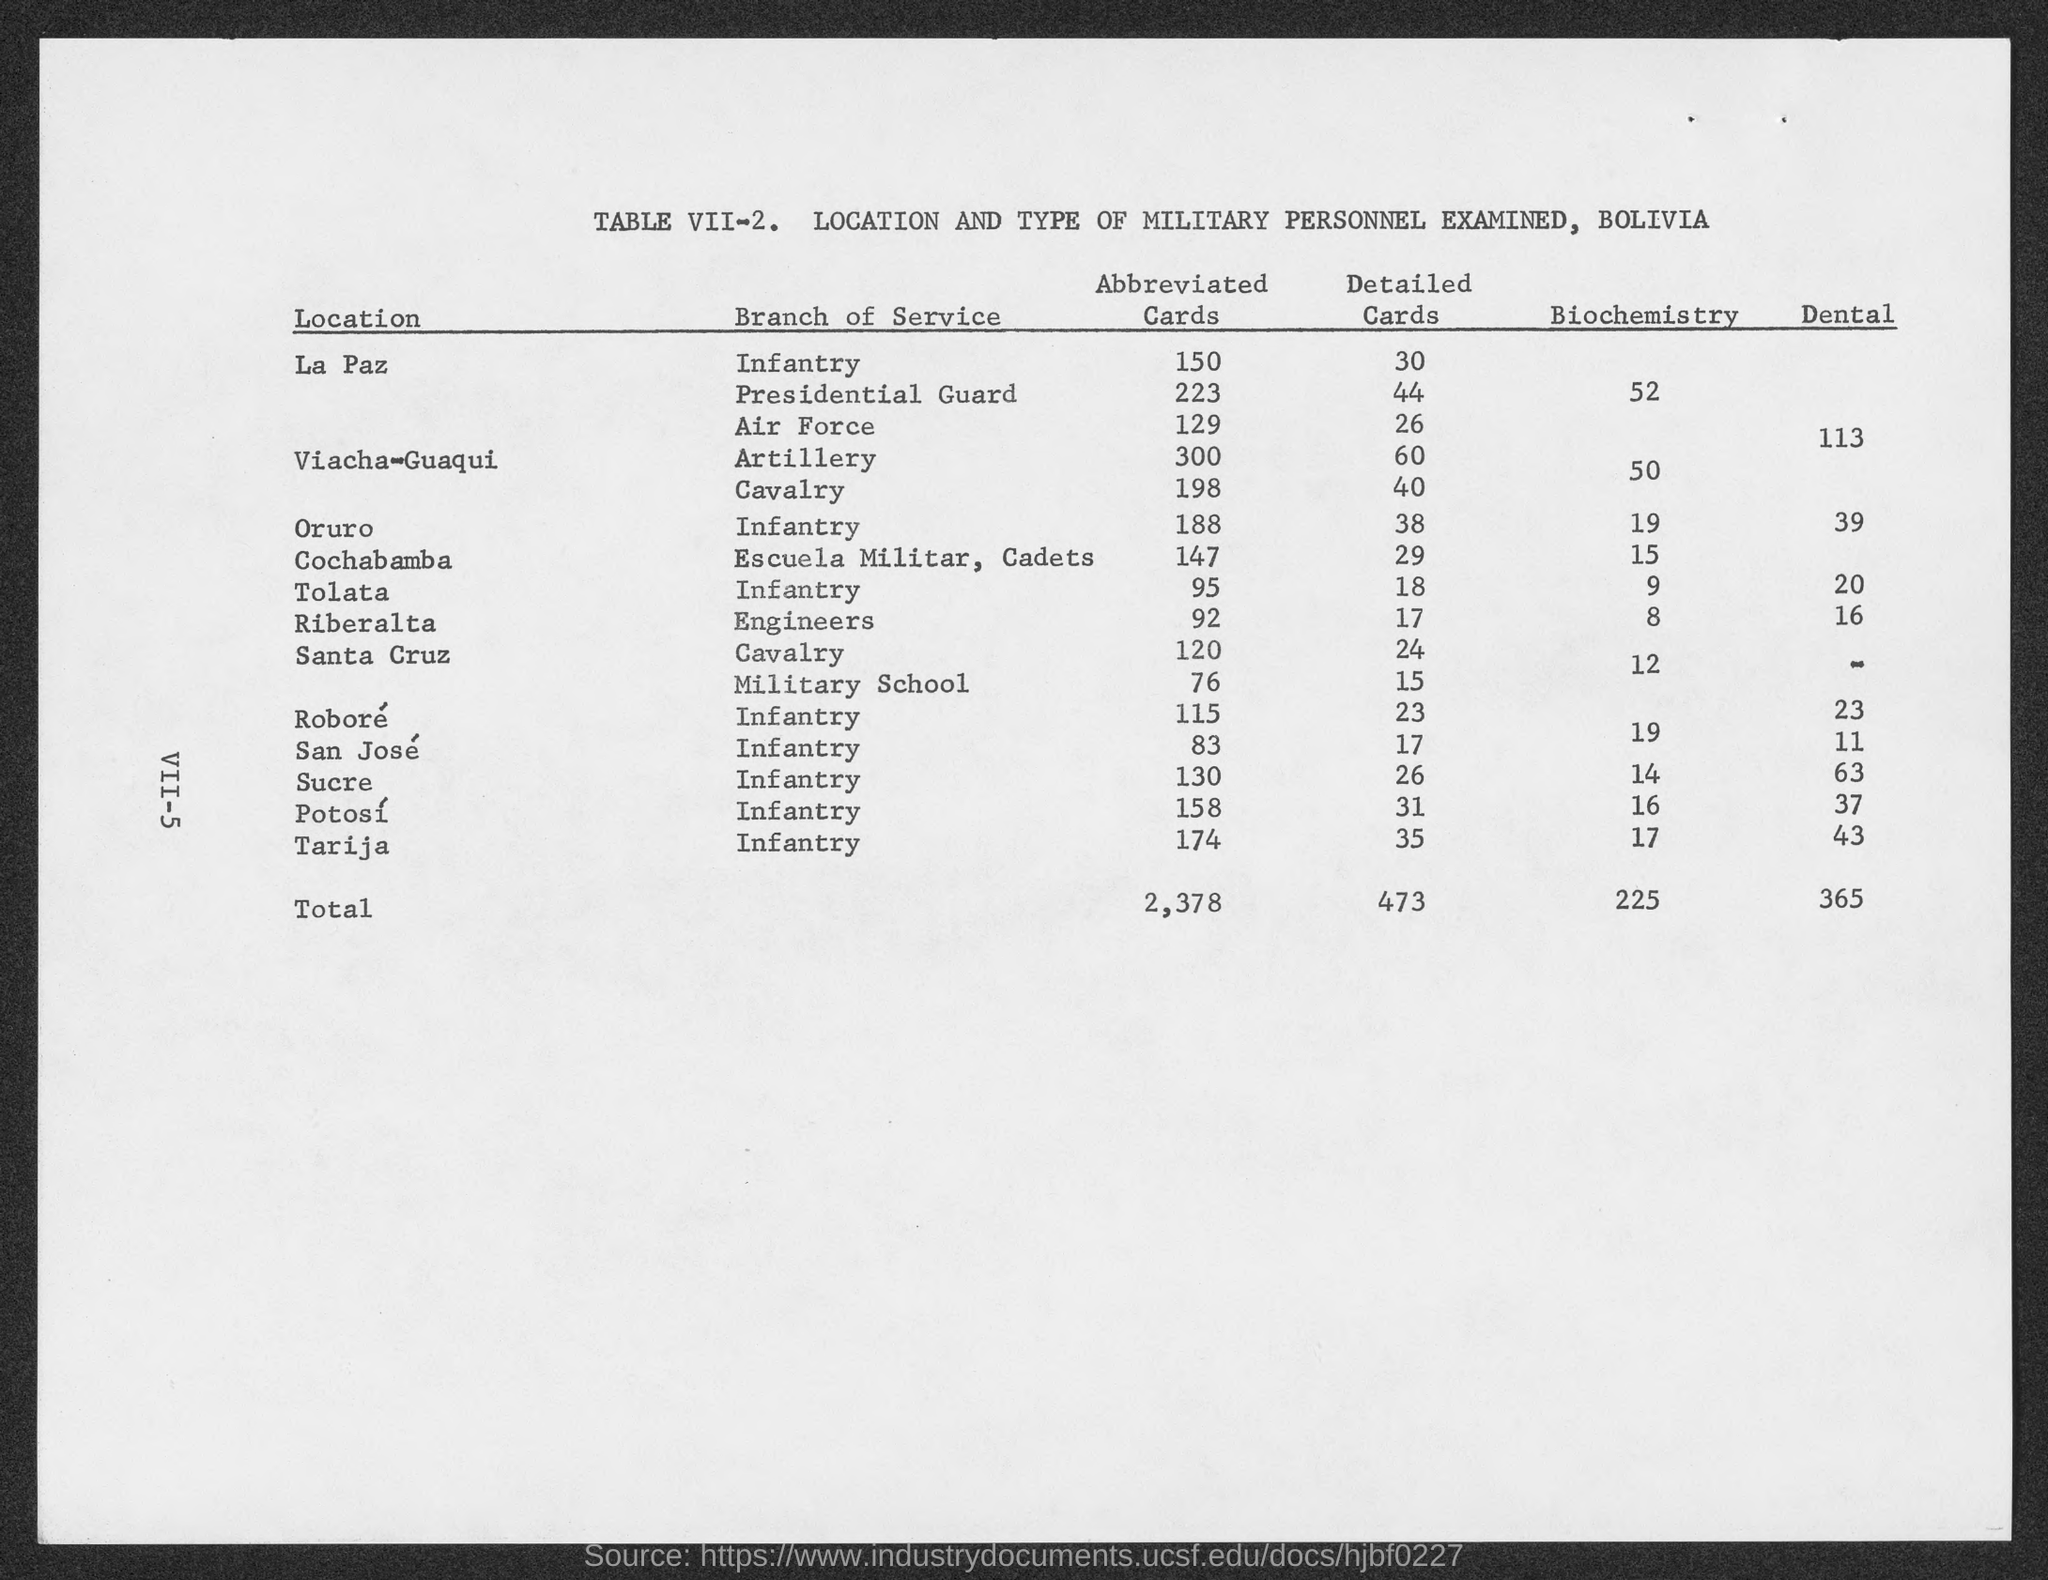What is the total of abbreviated cards?
Your answer should be very brief. 2,378. What is the total of detailed cards ?
Offer a terse response. 473. What is the total of biochemistry ?
Give a very brief answer. 225. What is the total of dental?
Ensure brevity in your answer.  365. 